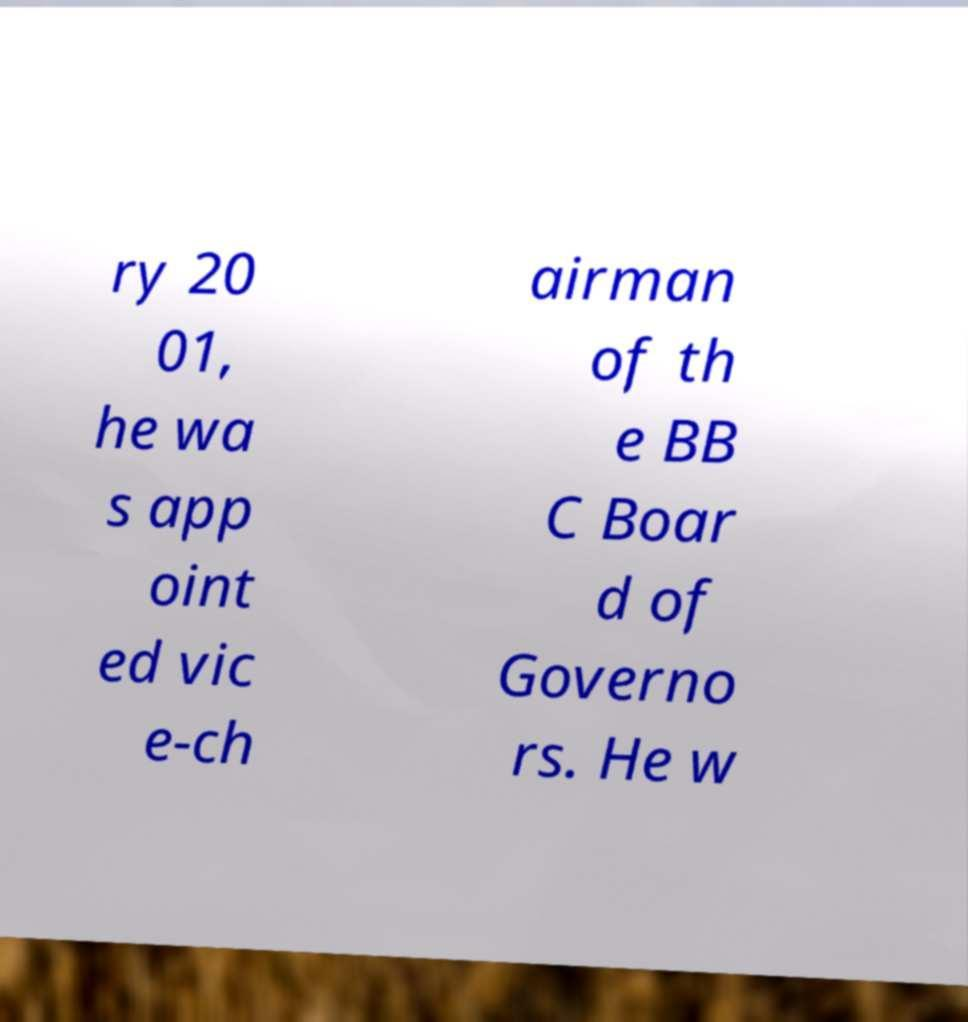Can you accurately transcribe the text from the provided image for me? ry 20 01, he wa s app oint ed vic e-ch airman of th e BB C Boar d of Governo rs. He w 